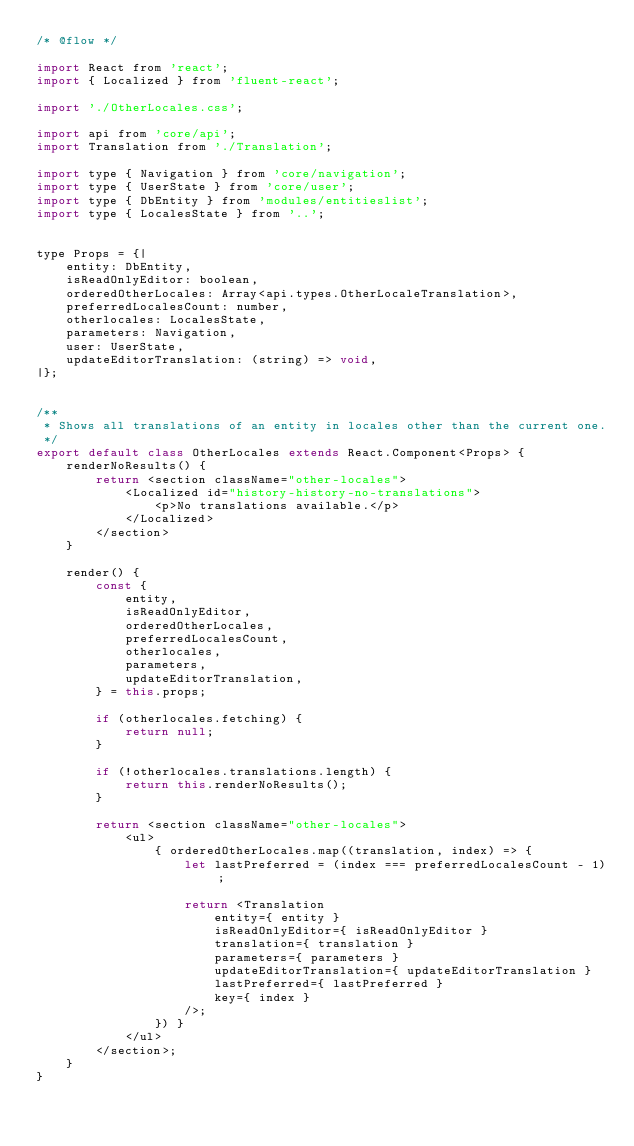Convert code to text. <code><loc_0><loc_0><loc_500><loc_500><_JavaScript_>/* @flow */

import React from 'react';
import { Localized } from 'fluent-react';

import './OtherLocales.css';

import api from 'core/api';
import Translation from './Translation';

import type { Navigation } from 'core/navigation';
import type { UserState } from 'core/user';
import type { DbEntity } from 'modules/entitieslist';
import type { LocalesState } from '..';


type Props = {|
    entity: DbEntity,
    isReadOnlyEditor: boolean,
    orderedOtherLocales: Array<api.types.OtherLocaleTranslation>,
    preferredLocalesCount: number,
    otherlocales: LocalesState,
    parameters: Navigation,
    user: UserState,
    updateEditorTranslation: (string) => void,
|};


/**
 * Shows all translations of an entity in locales other than the current one.
 */
export default class OtherLocales extends React.Component<Props> {
    renderNoResults() {
        return <section className="other-locales">
            <Localized id="history-history-no-translations">
                <p>No translations available.</p>
            </Localized>
        </section>
    }

    render() {
        const {
            entity,
            isReadOnlyEditor,
            orderedOtherLocales,
            preferredLocalesCount,
            otherlocales,
            parameters,
            updateEditorTranslation,
        } = this.props;

        if (otherlocales.fetching) {
            return null;
        }

        if (!otherlocales.translations.length) {
            return this.renderNoResults();
        }

        return <section className="other-locales">
            <ul>
                { orderedOtherLocales.map((translation, index) => {
                    let lastPreferred = (index === preferredLocalesCount - 1);

                    return <Translation
                        entity={ entity }
                        isReadOnlyEditor={ isReadOnlyEditor }
                        translation={ translation }
                        parameters={ parameters }
                        updateEditorTranslation={ updateEditorTranslation }
                        lastPreferred={ lastPreferred }
                        key={ index }
                    />;
                }) }
            </ul>
        </section>;
    }
}
</code> 